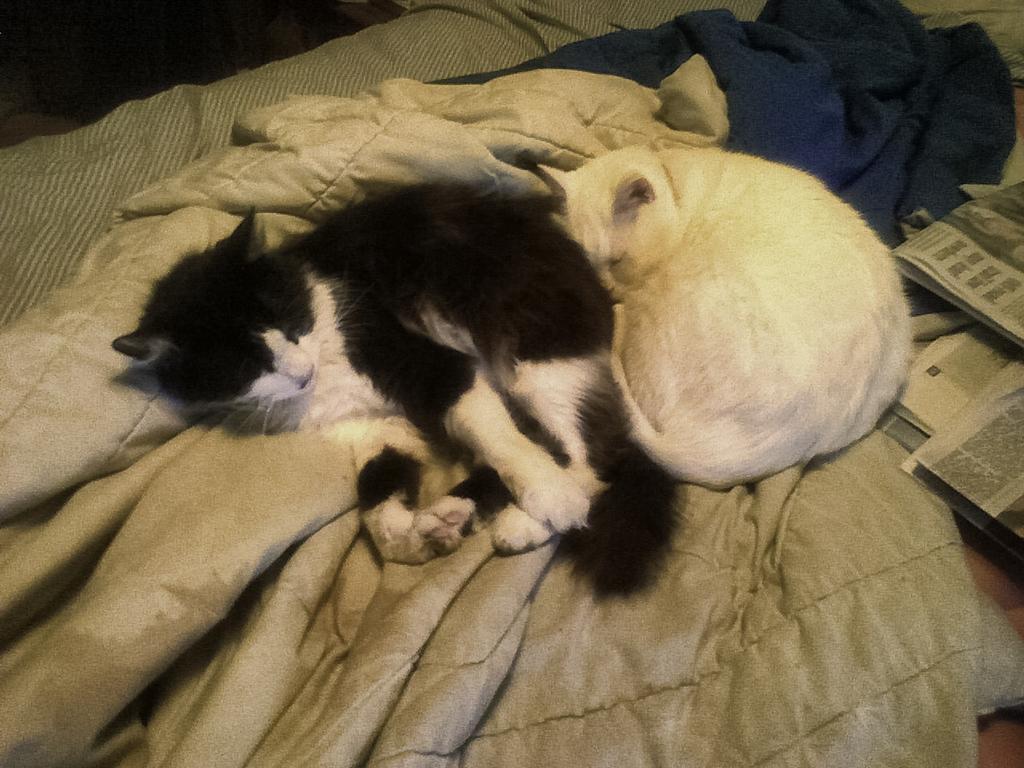In one or two sentences, can you explain what this image depicts? In this image we can see cats, blankets and a bed. On the right side, we can see the newspapers. 